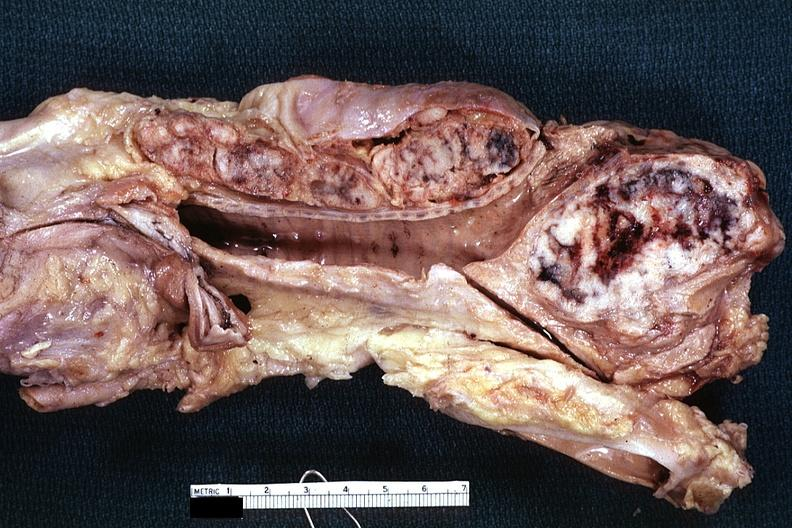what does this image show?
Answer the question using a single word or phrase. Fixed tissue excellent example of massively enlarged subcarinal and peritracheal nodes with metastatic lung cancer 